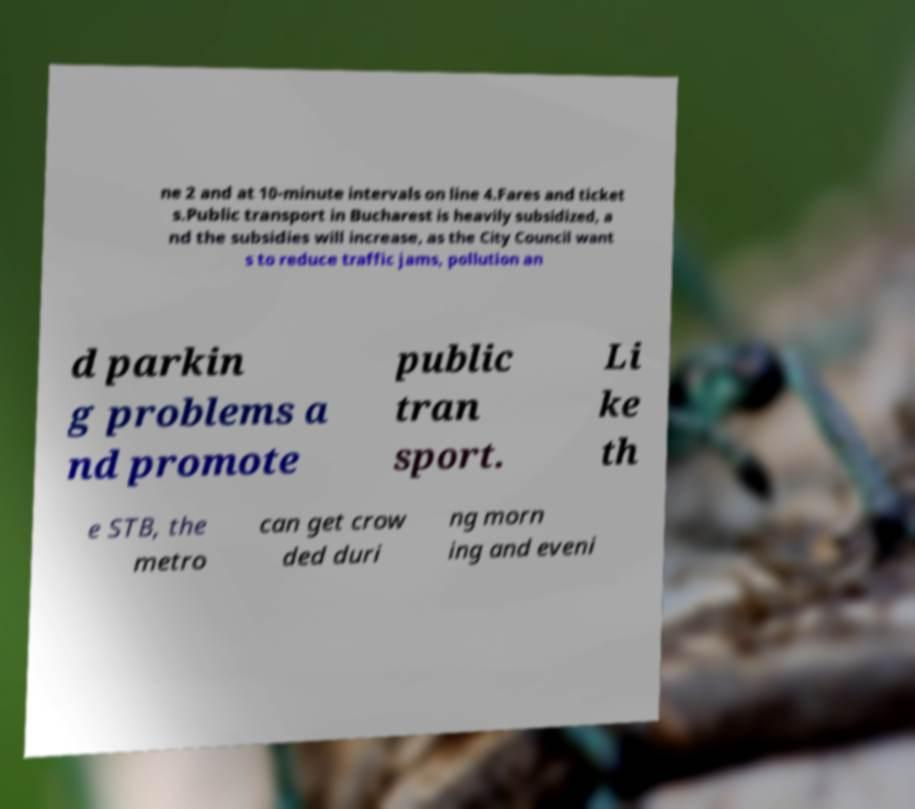I need the written content from this picture converted into text. Can you do that? ne 2 and at 10-minute intervals on line 4.Fares and ticket s.Public transport in Bucharest is heavily subsidized, a nd the subsidies will increase, as the City Council want s to reduce traffic jams, pollution an d parkin g problems a nd promote public tran sport. Li ke th e STB, the metro can get crow ded duri ng morn ing and eveni 